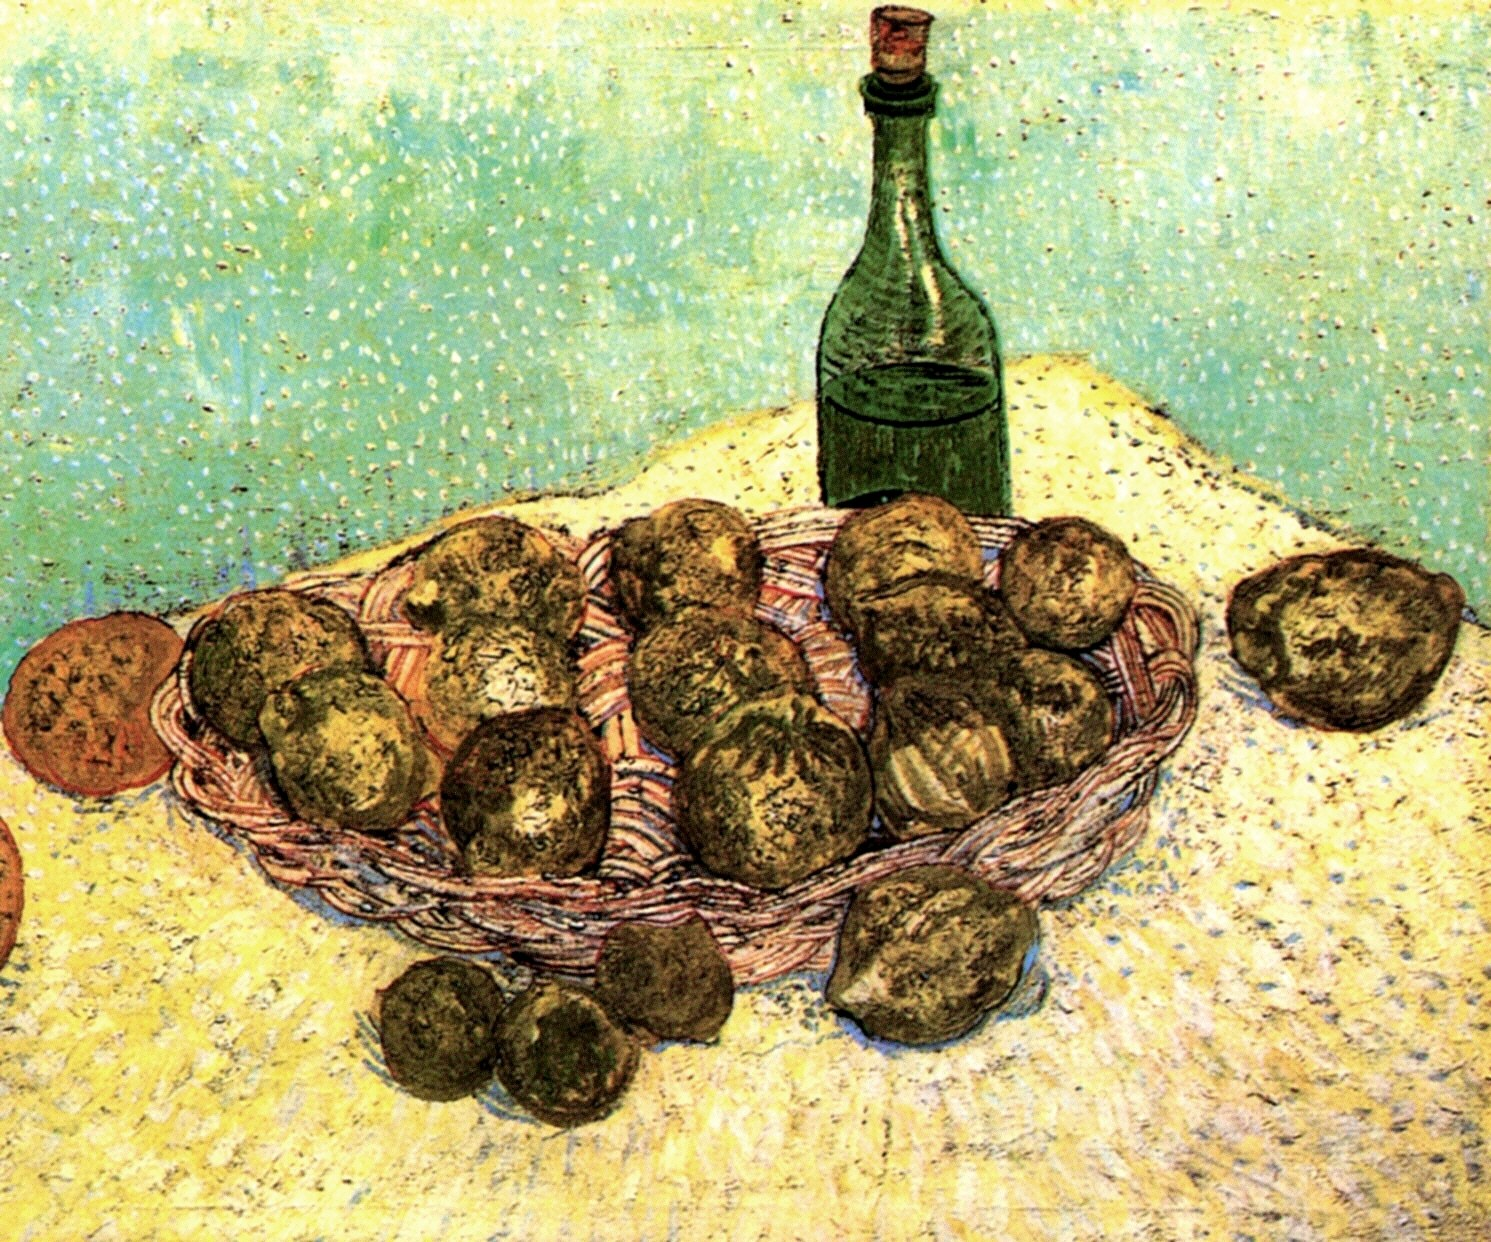What does the choice of objects in this painting signify? The objects in this painting, a basket of potatoes and a green bottle, are suggestive of simplicity and everyday life. Potatoes, being a staple food item, reflect sustenance and humility, elements often celebrated in post-impressionist works. The inclusion of the green bottle might suggest themes of leisure or daily consumption. Together, these elements could symbolize the beauty found in daily life and the rustic charm of simplicity, aligning with the post-impressionist focus on portraying the ordinary in extraordinary ways. 